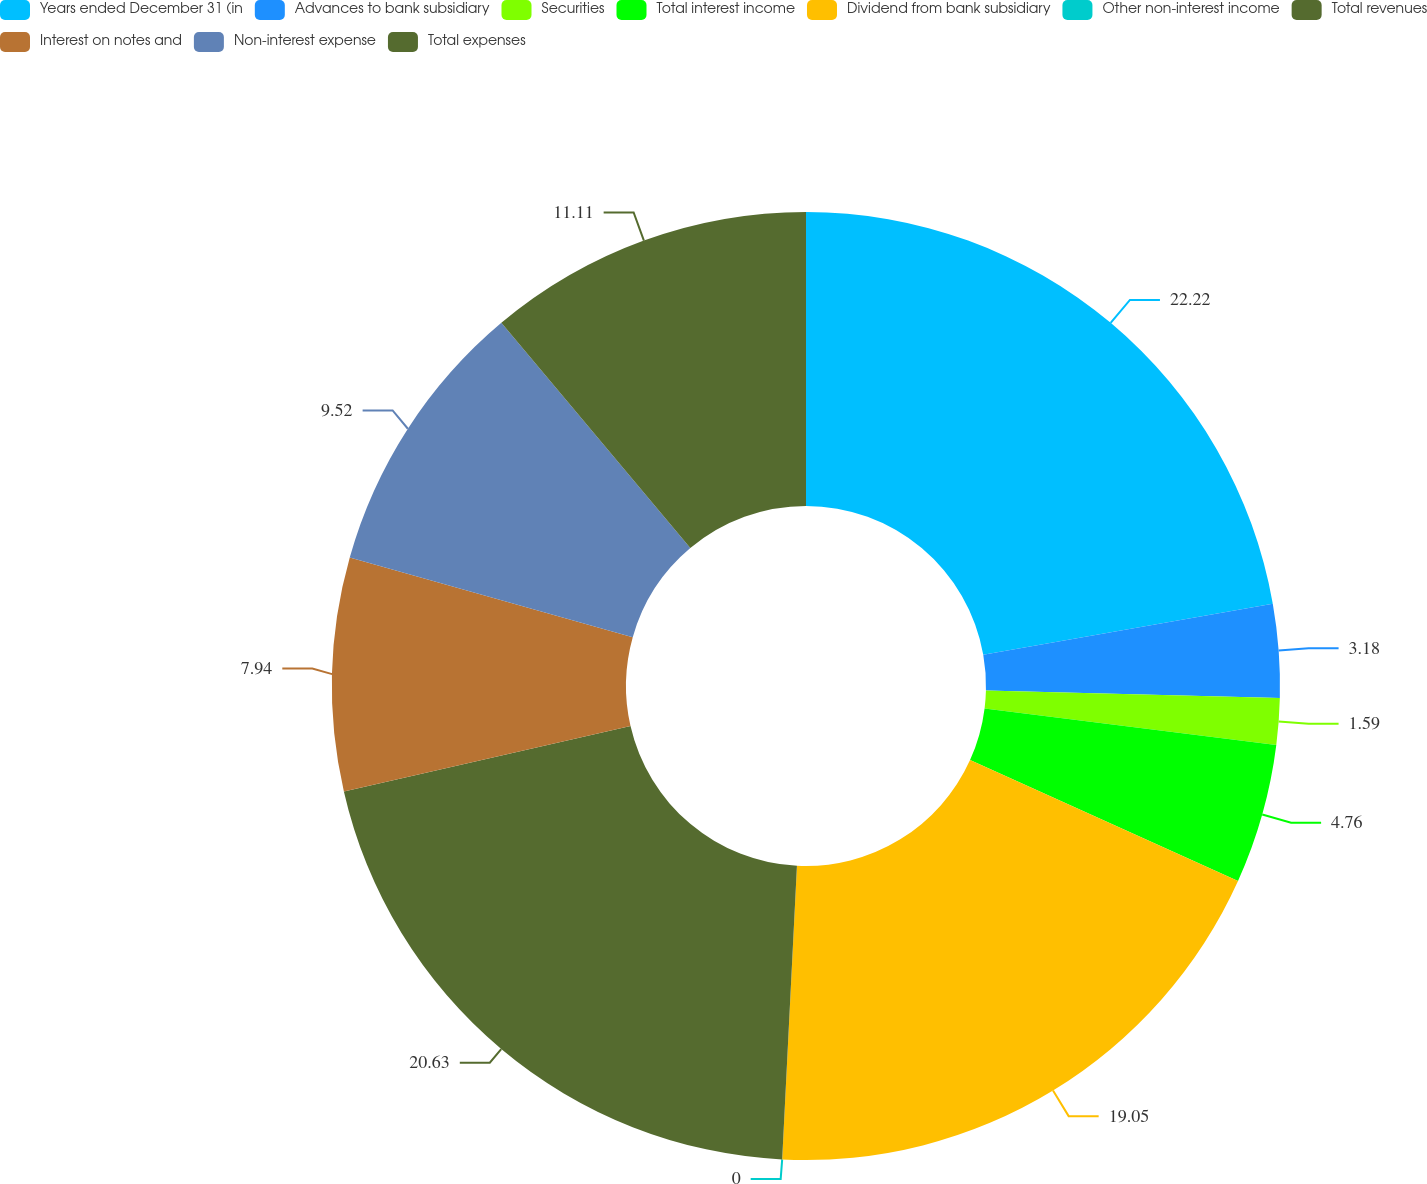Convert chart to OTSL. <chart><loc_0><loc_0><loc_500><loc_500><pie_chart><fcel>Years ended December 31 (in<fcel>Advances to bank subsidiary<fcel>Securities<fcel>Total interest income<fcel>Dividend from bank subsidiary<fcel>Other non-interest income<fcel>Total revenues<fcel>Interest on notes and<fcel>Non-interest expense<fcel>Total expenses<nl><fcel>22.22%<fcel>3.18%<fcel>1.59%<fcel>4.76%<fcel>19.05%<fcel>0.0%<fcel>20.63%<fcel>7.94%<fcel>9.52%<fcel>11.11%<nl></chart> 